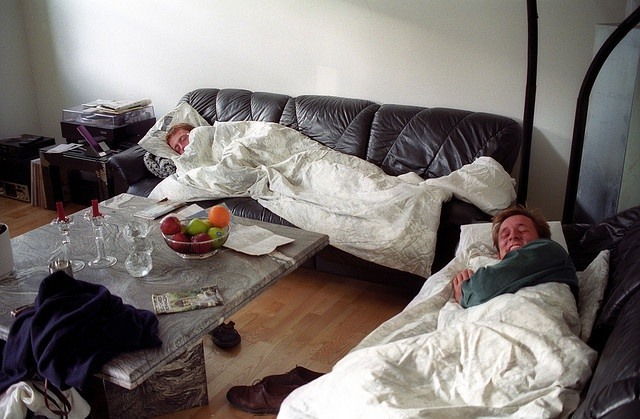Describe the objects in this image and their specific colors. I can see couch in gray, black, darkgray, and lightgray tones, couch in gray, black, lightgray, and darkgray tones, people in gray, black, maroon, and brown tones, bowl in gray, maroon, black, and olive tones, and apple in gray, maroon, black, and olive tones in this image. 